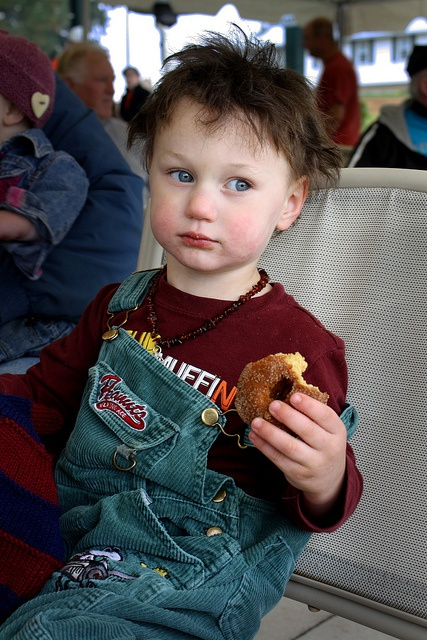Describe the objects in this image and their specific colors. I can see people in darkgreen, black, teal, maroon, and lightpink tones, chair in darkgreen, darkgray, gray, black, and lightgray tones, people in darkgreen, black, navy, darkblue, and gray tones, people in darkgreen, black, navy, maroon, and gray tones, and people in darkgreen, black, maroon, and gray tones in this image. 